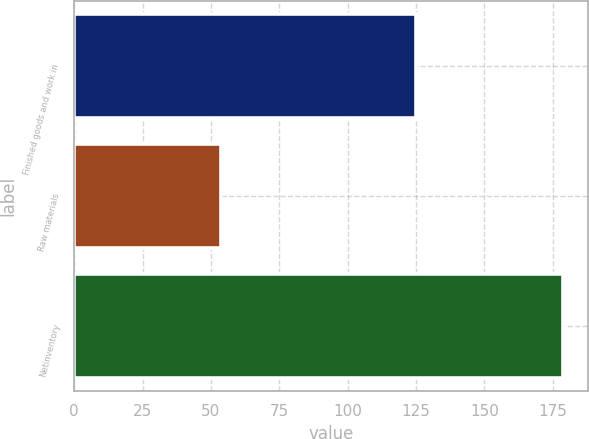Convert chart to OTSL. <chart><loc_0><loc_0><loc_500><loc_500><bar_chart><fcel>Finished goods and work in<fcel>Raw materials<fcel>Netinventory<nl><fcel>125.1<fcel>53.7<fcel>178.8<nl></chart> 